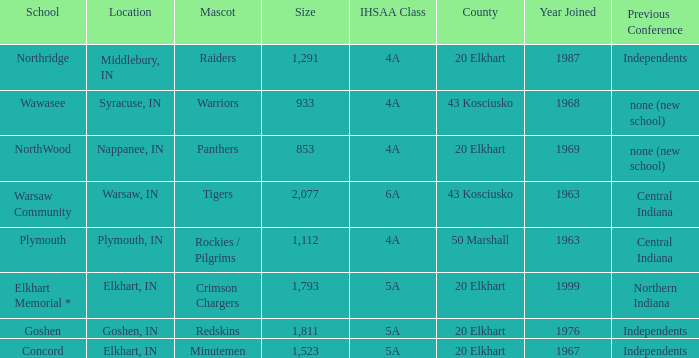What country joined before 1976, with IHSSA class of 5a, and a size larger than 1,112? 20 Elkhart. 